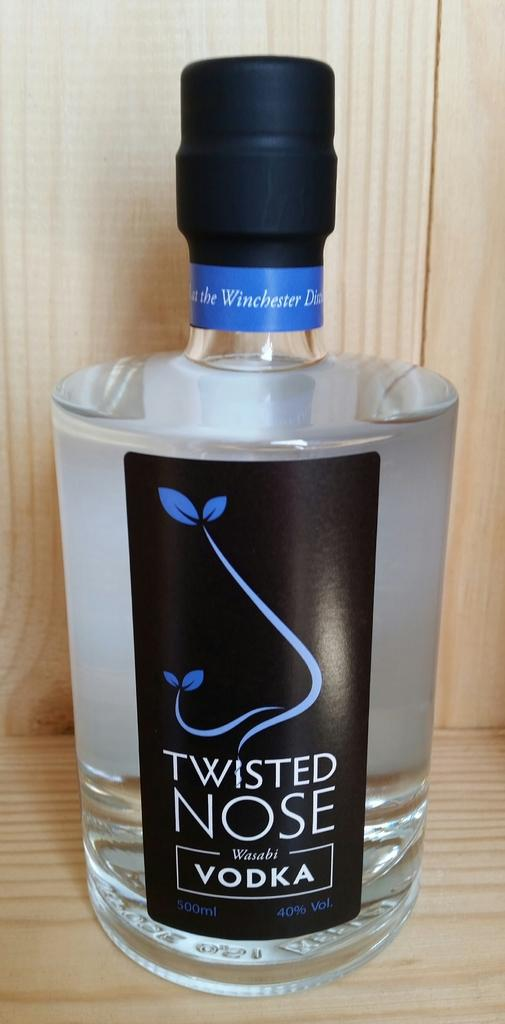<image>
Share a concise interpretation of the image provided. Twisted Nose Vodka product from the Winchester District. 